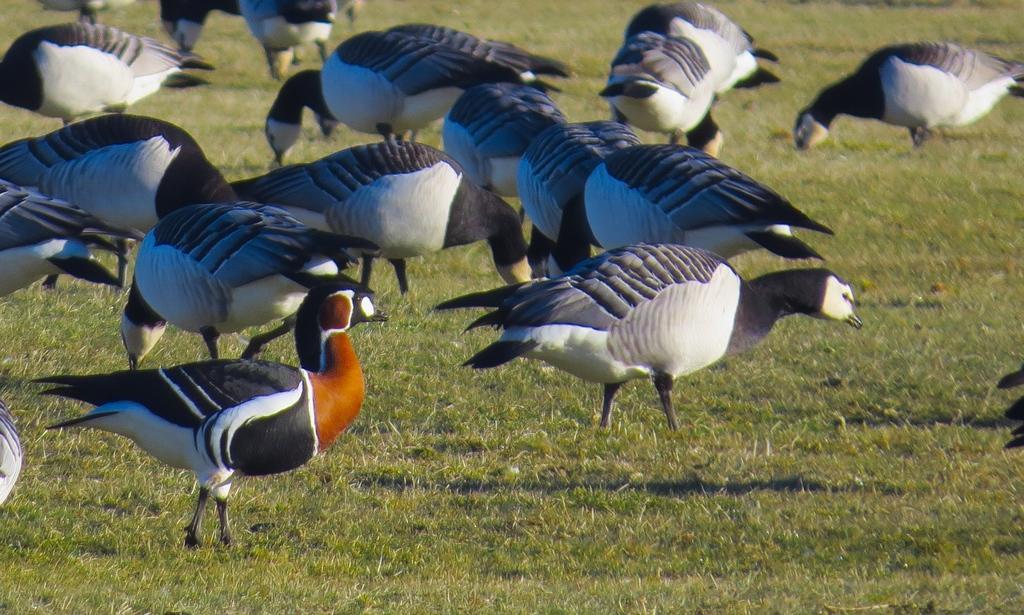How would you summarize this image in a sentence or two? In this picture I can see the grass ground, on which I can see number of words which are standing. 